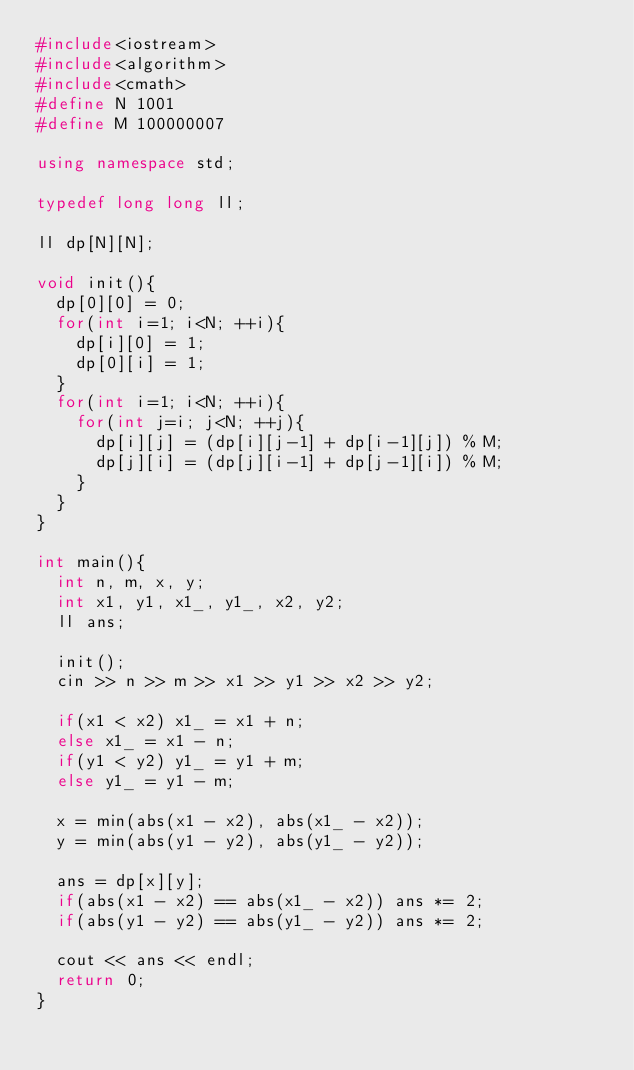<code> <loc_0><loc_0><loc_500><loc_500><_C++_>#include<iostream>
#include<algorithm>
#include<cmath>
#define N 1001
#define M 100000007

using namespace std;

typedef long long ll;

ll dp[N][N];

void init(){
  dp[0][0] = 0;
  for(int i=1; i<N; ++i){
    dp[i][0] = 1;
    dp[0][i] = 1;
  }
  for(int i=1; i<N; ++i){
    for(int j=i; j<N; ++j){
      dp[i][j] = (dp[i][j-1] + dp[i-1][j]) % M;
      dp[j][i] = (dp[j][i-1] + dp[j-1][i]) % M;
    }
  }
}

int main(){
  int n, m, x, y;
  int x1, y1, x1_, y1_, x2, y2;
  ll ans;

  init();
  cin >> n >> m >> x1 >> y1 >> x2 >> y2;

  if(x1 < x2) x1_ = x1 + n;
  else x1_ = x1 - n;
  if(y1 < y2) y1_ = y1 + m;
  else y1_ = y1 - m;

  x = min(abs(x1 - x2), abs(x1_ - x2));
  y = min(abs(y1 - y2), abs(y1_ - y2));

  ans = dp[x][y];
  if(abs(x1 - x2) == abs(x1_ - x2)) ans *= 2;
  if(abs(y1 - y2) == abs(y1_ - y2)) ans *= 2;

  cout << ans << endl;
  return 0;
}</code> 